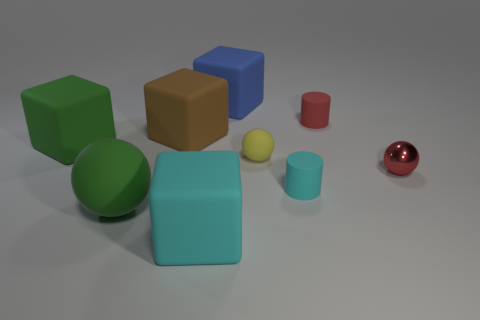Subtract all big blue cubes. How many cubes are left? 3 Subtract all red balls. How many balls are left? 2 Subtract 3 spheres. How many spheres are left? 0 Subtract all balls. How many objects are left? 6 Add 2 large gray cylinders. How many large gray cylinders exist? 2 Subtract 0 blue cylinders. How many objects are left? 9 Subtract all cyan spheres. Subtract all brown cubes. How many spheres are left? 3 Subtract all big rubber spheres. Subtract all blue objects. How many objects are left? 7 Add 7 small yellow matte spheres. How many small yellow matte spheres are left? 8 